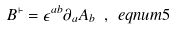<formula> <loc_0><loc_0><loc_500><loc_500>B ^ { \vdash } = \epsilon ^ { a b } \partial _ { a } A _ { b } \ , \ e q n u m { 5 }</formula> 